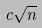Convert formula to latex. <formula><loc_0><loc_0><loc_500><loc_500>c \sqrt { n }</formula> 